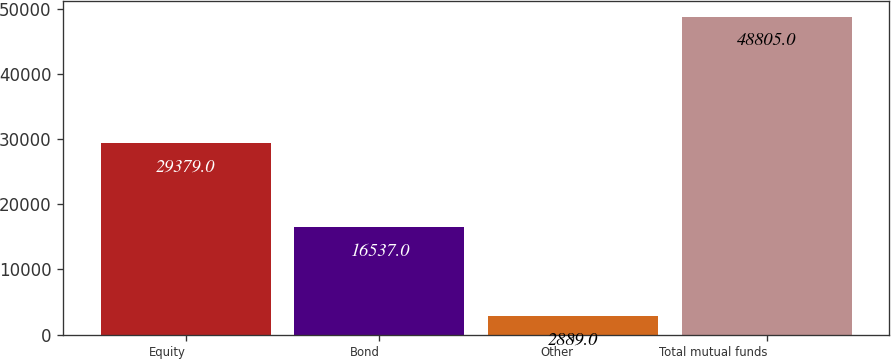Convert chart. <chart><loc_0><loc_0><loc_500><loc_500><bar_chart><fcel>Equity<fcel>Bond<fcel>Other<fcel>Total mutual funds<nl><fcel>29379<fcel>16537<fcel>2889<fcel>48805<nl></chart> 